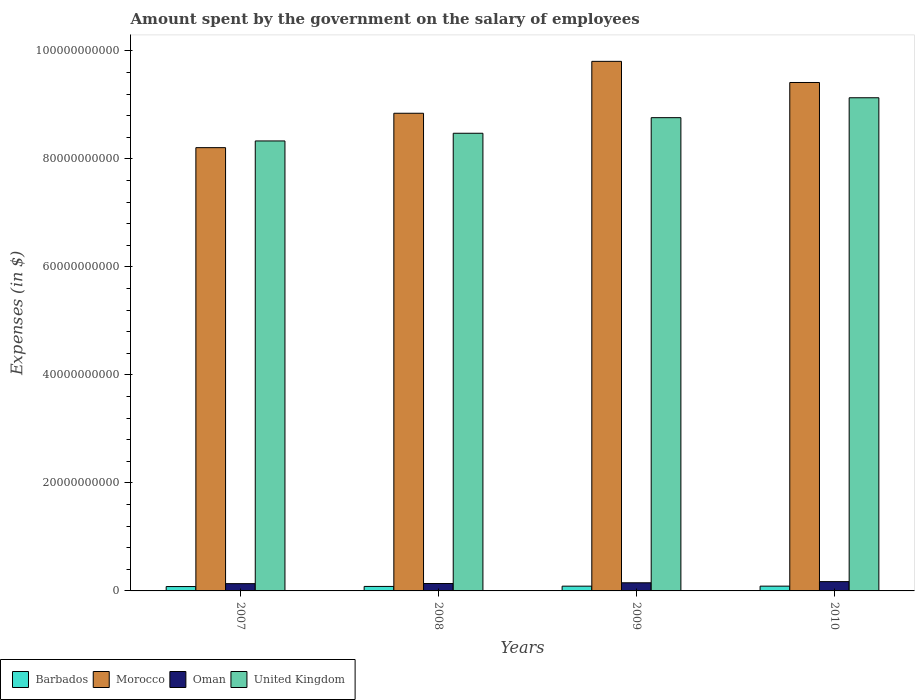How many groups of bars are there?
Keep it short and to the point. 4. Are the number of bars per tick equal to the number of legend labels?
Give a very brief answer. Yes. Are the number of bars on each tick of the X-axis equal?
Your answer should be compact. Yes. How many bars are there on the 4th tick from the left?
Your response must be concise. 4. What is the label of the 3rd group of bars from the left?
Your answer should be compact. 2009. What is the amount spent on the salary of employees by the government in United Kingdom in 2008?
Make the answer very short. 8.48e+1. Across all years, what is the maximum amount spent on the salary of employees by the government in Oman?
Provide a succinct answer. 1.72e+09. Across all years, what is the minimum amount spent on the salary of employees by the government in Barbados?
Your answer should be compact. 8.09e+08. In which year was the amount spent on the salary of employees by the government in United Kingdom maximum?
Offer a very short reply. 2010. In which year was the amount spent on the salary of employees by the government in Oman minimum?
Offer a terse response. 2007. What is the total amount spent on the salary of employees by the government in Oman in the graph?
Offer a very short reply. 5.95e+09. What is the difference between the amount spent on the salary of employees by the government in Oman in 2009 and that in 2010?
Your answer should be very brief. -2.16e+08. What is the difference between the amount spent on the salary of employees by the government in Oman in 2007 and the amount spent on the salary of employees by the government in United Kingdom in 2010?
Give a very brief answer. -9.00e+1. What is the average amount spent on the salary of employees by the government in United Kingdom per year?
Provide a short and direct response. 8.68e+1. In the year 2009, what is the difference between the amount spent on the salary of employees by the government in Barbados and amount spent on the salary of employees by the government in United Kingdom?
Make the answer very short. -8.68e+1. What is the ratio of the amount spent on the salary of employees by the government in Barbados in 2007 to that in 2008?
Offer a terse response. 0.97. What is the difference between the highest and the second highest amount spent on the salary of employees by the government in United Kingdom?
Ensure brevity in your answer.  3.69e+09. What is the difference between the highest and the lowest amount spent on the salary of employees by the government in Morocco?
Provide a succinct answer. 1.60e+1. What does the 4th bar from the left in 2007 represents?
Ensure brevity in your answer.  United Kingdom. What does the 3rd bar from the right in 2009 represents?
Offer a very short reply. Morocco. Are all the bars in the graph horizontal?
Your response must be concise. No. Are the values on the major ticks of Y-axis written in scientific E-notation?
Keep it short and to the point. No. Does the graph contain any zero values?
Ensure brevity in your answer.  No. Does the graph contain grids?
Make the answer very short. No. Where does the legend appear in the graph?
Offer a very short reply. Bottom left. What is the title of the graph?
Keep it short and to the point. Amount spent by the government on the salary of employees. What is the label or title of the X-axis?
Your response must be concise. Years. What is the label or title of the Y-axis?
Offer a very short reply. Expenses (in $). What is the Expenses (in $) of Barbados in 2007?
Offer a very short reply. 8.09e+08. What is the Expenses (in $) of Morocco in 2007?
Your answer should be compact. 8.21e+1. What is the Expenses (in $) of Oman in 2007?
Your response must be concise. 1.35e+09. What is the Expenses (in $) in United Kingdom in 2007?
Offer a terse response. 8.33e+1. What is the Expenses (in $) in Barbados in 2008?
Give a very brief answer. 8.33e+08. What is the Expenses (in $) of Morocco in 2008?
Make the answer very short. 8.85e+1. What is the Expenses (in $) of Oman in 2008?
Make the answer very short. 1.37e+09. What is the Expenses (in $) of United Kingdom in 2008?
Offer a very short reply. 8.48e+1. What is the Expenses (in $) in Barbados in 2009?
Provide a short and direct response. 8.82e+08. What is the Expenses (in $) in Morocco in 2009?
Give a very brief answer. 9.81e+1. What is the Expenses (in $) in Oman in 2009?
Provide a short and direct response. 1.51e+09. What is the Expenses (in $) in United Kingdom in 2009?
Your answer should be compact. 8.77e+1. What is the Expenses (in $) in Barbados in 2010?
Offer a terse response. 8.85e+08. What is the Expenses (in $) in Morocco in 2010?
Provide a succinct answer. 9.42e+1. What is the Expenses (in $) of Oman in 2010?
Give a very brief answer. 1.72e+09. What is the Expenses (in $) of United Kingdom in 2010?
Give a very brief answer. 9.13e+1. Across all years, what is the maximum Expenses (in $) of Barbados?
Give a very brief answer. 8.85e+08. Across all years, what is the maximum Expenses (in $) in Morocco?
Your response must be concise. 9.81e+1. Across all years, what is the maximum Expenses (in $) of Oman?
Your response must be concise. 1.72e+09. Across all years, what is the maximum Expenses (in $) of United Kingdom?
Your answer should be compact. 9.13e+1. Across all years, what is the minimum Expenses (in $) in Barbados?
Your answer should be compact. 8.09e+08. Across all years, what is the minimum Expenses (in $) in Morocco?
Your response must be concise. 8.21e+1. Across all years, what is the minimum Expenses (in $) in Oman?
Your response must be concise. 1.35e+09. Across all years, what is the minimum Expenses (in $) in United Kingdom?
Ensure brevity in your answer.  8.33e+1. What is the total Expenses (in $) in Barbados in the graph?
Ensure brevity in your answer.  3.41e+09. What is the total Expenses (in $) in Morocco in the graph?
Give a very brief answer. 3.63e+11. What is the total Expenses (in $) of Oman in the graph?
Your response must be concise. 5.95e+09. What is the total Expenses (in $) of United Kingdom in the graph?
Ensure brevity in your answer.  3.47e+11. What is the difference between the Expenses (in $) in Barbados in 2007 and that in 2008?
Keep it short and to the point. -2.35e+07. What is the difference between the Expenses (in $) of Morocco in 2007 and that in 2008?
Your answer should be compact. -6.37e+09. What is the difference between the Expenses (in $) of Oman in 2007 and that in 2008?
Your response must be concise. -2.13e+07. What is the difference between the Expenses (in $) of United Kingdom in 2007 and that in 2008?
Provide a succinct answer. -1.42e+09. What is the difference between the Expenses (in $) of Barbados in 2007 and that in 2009?
Keep it short and to the point. -7.31e+07. What is the difference between the Expenses (in $) of Morocco in 2007 and that in 2009?
Make the answer very short. -1.60e+1. What is the difference between the Expenses (in $) of Oman in 2007 and that in 2009?
Make the answer very short. -1.59e+08. What is the difference between the Expenses (in $) of United Kingdom in 2007 and that in 2009?
Your answer should be very brief. -4.31e+09. What is the difference between the Expenses (in $) of Barbados in 2007 and that in 2010?
Offer a very short reply. -7.60e+07. What is the difference between the Expenses (in $) of Morocco in 2007 and that in 2010?
Ensure brevity in your answer.  -1.21e+1. What is the difference between the Expenses (in $) of Oman in 2007 and that in 2010?
Offer a terse response. -3.75e+08. What is the difference between the Expenses (in $) in United Kingdom in 2007 and that in 2010?
Keep it short and to the point. -8.00e+09. What is the difference between the Expenses (in $) of Barbados in 2008 and that in 2009?
Offer a terse response. -4.96e+07. What is the difference between the Expenses (in $) in Morocco in 2008 and that in 2009?
Offer a terse response. -9.61e+09. What is the difference between the Expenses (in $) of Oman in 2008 and that in 2009?
Offer a terse response. -1.37e+08. What is the difference between the Expenses (in $) in United Kingdom in 2008 and that in 2009?
Provide a short and direct response. -2.89e+09. What is the difference between the Expenses (in $) of Barbados in 2008 and that in 2010?
Keep it short and to the point. -5.24e+07. What is the difference between the Expenses (in $) of Morocco in 2008 and that in 2010?
Your answer should be compact. -5.70e+09. What is the difference between the Expenses (in $) in Oman in 2008 and that in 2010?
Give a very brief answer. -3.54e+08. What is the difference between the Expenses (in $) in United Kingdom in 2008 and that in 2010?
Provide a succinct answer. -6.58e+09. What is the difference between the Expenses (in $) of Barbados in 2009 and that in 2010?
Provide a succinct answer. -2.85e+06. What is the difference between the Expenses (in $) in Morocco in 2009 and that in 2010?
Your response must be concise. 3.92e+09. What is the difference between the Expenses (in $) of Oman in 2009 and that in 2010?
Ensure brevity in your answer.  -2.16e+08. What is the difference between the Expenses (in $) in United Kingdom in 2009 and that in 2010?
Your response must be concise. -3.69e+09. What is the difference between the Expenses (in $) in Barbados in 2007 and the Expenses (in $) in Morocco in 2008?
Offer a terse response. -8.77e+1. What is the difference between the Expenses (in $) in Barbados in 2007 and the Expenses (in $) in Oman in 2008?
Provide a short and direct response. -5.60e+08. What is the difference between the Expenses (in $) in Barbados in 2007 and the Expenses (in $) in United Kingdom in 2008?
Give a very brief answer. -8.40e+1. What is the difference between the Expenses (in $) of Morocco in 2007 and the Expenses (in $) of Oman in 2008?
Ensure brevity in your answer.  8.07e+1. What is the difference between the Expenses (in $) in Morocco in 2007 and the Expenses (in $) in United Kingdom in 2008?
Give a very brief answer. -2.67e+09. What is the difference between the Expenses (in $) in Oman in 2007 and the Expenses (in $) in United Kingdom in 2008?
Offer a very short reply. -8.34e+1. What is the difference between the Expenses (in $) of Barbados in 2007 and the Expenses (in $) of Morocco in 2009?
Provide a short and direct response. -9.73e+1. What is the difference between the Expenses (in $) of Barbados in 2007 and the Expenses (in $) of Oman in 2009?
Provide a short and direct response. -6.97e+08. What is the difference between the Expenses (in $) in Barbados in 2007 and the Expenses (in $) in United Kingdom in 2009?
Give a very brief answer. -8.68e+1. What is the difference between the Expenses (in $) of Morocco in 2007 and the Expenses (in $) of Oman in 2009?
Offer a terse response. 8.06e+1. What is the difference between the Expenses (in $) of Morocco in 2007 and the Expenses (in $) of United Kingdom in 2009?
Offer a very short reply. -5.55e+09. What is the difference between the Expenses (in $) of Oman in 2007 and the Expenses (in $) of United Kingdom in 2009?
Your answer should be compact. -8.63e+1. What is the difference between the Expenses (in $) in Barbados in 2007 and the Expenses (in $) in Morocco in 2010?
Your response must be concise. -9.34e+1. What is the difference between the Expenses (in $) in Barbados in 2007 and the Expenses (in $) in Oman in 2010?
Your answer should be very brief. -9.14e+08. What is the difference between the Expenses (in $) of Barbados in 2007 and the Expenses (in $) of United Kingdom in 2010?
Your answer should be very brief. -9.05e+1. What is the difference between the Expenses (in $) in Morocco in 2007 and the Expenses (in $) in Oman in 2010?
Ensure brevity in your answer.  8.04e+1. What is the difference between the Expenses (in $) in Morocco in 2007 and the Expenses (in $) in United Kingdom in 2010?
Give a very brief answer. -9.24e+09. What is the difference between the Expenses (in $) of Oman in 2007 and the Expenses (in $) of United Kingdom in 2010?
Make the answer very short. -9.00e+1. What is the difference between the Expenses (in $) in Barbados in 2008 and the Expenses (in $) in Morocco in 2009?
Your response must be concise. -9.72e+1. What is the difference between the Expenses (in $) in Barbados in 2008 and the Expenses (in $) in Oman in 2009?
Your response must be concise. -6.74e+08. What is the difference between the Expenses (in $) in Barbados in 2008 and the Expenses (in $) in United Kingdom in 2009?
Provide a succinct answer. -8.68e+1. What is the difference between the Expenses (in $) in Morocco in 2008 and the Expenses (in $) in Oman in 2009?
Provide a succinct answer. 8.70e+1. What is the difference between the Expenses (in $) of Morocco in 2008 and the Expenses (in $) of United Kingdom in 2009?
Give a very brief answer. 8.17e+08. What is the difference between the Expenses (in $) of Oman in 2008 and the Expenses (in $) of United Kingdom in 2009?
Ensure brevity in your answer.  -8.63e+1. What is the difference between the Expenses (in $) of Barbados in 2008 and the Expenses (in $) of Morocco in 2010?
Ensure brevity in your answer.  -9.33e+1. What is the difference between the Expenses (in $) of Barbados in 2008 and the Expenses (in $) of Oman in 2010?
Ensure brevity in your answer.  -8.90e+08. What is the difference between the Expenses (in $) in Barbados in 2008 and the Expenses (in $) in United Kingdom in 2010?
Ensure brevity in your answer.  -9.05e+1. What is the difference between the Expenses (in $) of Morocco in 2008 and the Expenses (in $) of Oman in 2010?
Provide a succinct answer. 8.67e+1. What is the difference between the Expenses (in $) of Morocco in 2008 and the Expenses (in $) of United Kingdom in 2010?
Your answer should be very brief. -2.87e+09. What is the difference between the Expenses (in $) in Oman in 2008 and the Expenses (in $) in United Kingdom in 2010?
Ensure brevity in your answer.  -9.00e+1. What is the difference between the Expenses (in $) in Barbados in 2009 and the Expenses (in $) in Morocco in 2010?
Make the answer very short. -9.33e+1. What is the difference between the Expenses (in $) in Barbados in 2009 and the Expenses (in $) in Oman in 2010?
Your answer should be very brief. -8.40e+08. What is the difference between the Expenses (in $) of Barbados in 2009 and the Expenses (in $) of United Kingdom in 2010?
Provide a short and direct response. -9.05e+1. What is the difference between the Expenses (in $) of Morocco in 2009 and the Expenses (in $) of Oman in 2010?
Your answer should be compact. 9.64e+1. What is the difference between the Expenses (in $) in Morocco in 2009 and the Expenses (in $) in United Kingdom in 2010?
Offer a very short reply. 6.74e+09. What is the difference between the Expenses (in $) in Oman in 2009 and the Expenses (in $) in United Kingdom in 2010?
Provide a succinct answer. -8.98e+1. What is the average Expenses (in $) of Barbados per year?
Your answer should be very brief. 8.52e+08. What is the average Expenses (in $) in Morocco per year?
Ensure brevity in your answer.  9.07e+1. What is the average Expenses (in $) of Oman per year?
Your answer should be compact. 1.49e+09. What is the average Expenses (in $) of United Kingdom per year?
Your answer should be very brief. 8.68e+1. In the year 2007, what is the difference between the Expenses (in $) of Barbados and Expenses (in $) of Morocco?
Ensure brevity in your answer.  -8.13e+1. In the year 2007, what is the difference between the Expenses (in $) of Barbados and Expenses (in $) of Oman?
Your answer should be very brief. -5.39e+08. In the year 2007, what is the difference between the Expenses (in $) of Barbados and Expenses (in $) of United Kingdom?
Give a very brief answer. -8.25e+1. In the year 2007, what is the difference between the Expenses (in $) in Morocco and Expenses (in $) in Oman?
Your answer should be very brief. 8.07e+1. In the year 2007, what is the difference between the Expenses (in $) of Morocco and Expenses (in $) of United Kingdom?
Offer a terse response. -1.24e+09. In the year 2007, what is the difference between the Expenses (in $) of Oman and Expenses (in $) of United Kingdom?
Your answer should be very brief. -8.20e+1. In the year 2008, what is the difference between the Expenses (in $) of Barbados and Expenses (in $) of Morocco?
Make the answer very short. -8.76e+1. In the year 2008, what is the difference between the Expenses (in $) of Barbados and Expenses (in $) of Oman?
Your answer should be compact. -5.37e+08. In the year 2008, what is the difference between the Expenses (in $) in Barbados and Expenses (in $) in United Kingdom?
Your answer should be compact. -8.39e+1. In the year 2008, what is the difference between the Expenses (in $) in Morocco and Expenses (in $) in Oman?
Provide a succinct answer. 8.71e+1. In the year 2008, what is the difference between the Expenses (in $) in Morocco and Expenses (in $) in United Kingdom?
Your answer should be very brief. 3.71e+09. In the year 2008, what is the difference between the Expenses (in $) in Oman and Expenses (in $) in United Kingdom?
Offer a very short reply. -8.34e+1. In the year 2009, what is the difference between the Expenses (in $) of Barbados and Expenses (in $) of Morocco?
Provide a short and direct response. -9.72e+1. In the year 2009, what is the difference between the Expenses (in $) in Barbados and Expenses (in $) in Oman?
Make the answer very short. -6.24e+08. In the year 2009, what is the difference between the Expenses (in $) of Barbados and Expenses (in $) of United Kingdom?
Your response must be concise. -8.68e+1. In the year 2009, what is the difference between the Expenses (in $) of Morocco and Expenses (in $) of Oman?
Your response must be concise. 9.66e+1. In the year 2009, what is the difference between the Expenses (in $) in Morocco and Expenses (in $) in United Kingdom?
Make the answer very short. 1.04e+1. In the year 2009, what is the difference between the Expenses (in $) in Oman and Expenses (in $) in United Kingdom?
Make the answer very short. -8.61e+1. In the year 2010, what is the difference between the Expenses (in $) in Barbados and Expenses (in $) in Morocco?
Ensure brevity in your answer.  -9.33e+1. In the year 2010, what is the difference between the Expenses (in $) in Barbados and Expenses (in $) in Oman?
Your response must be concise. -8.38e+08. In the year 2010, what is the difference between the Expenses (in $) of Barbados and Expenses (in $) of United Kingdom?
Keep it short and to the point. -9.05e+1. In the year 2010, what is the difference between the Expenses (in $) in Morocco and Expenses (in $) in Oman?
Offer a very short reply. 9.24e+1. In the year 2010, what is the difference between the Expenses (in $) of Morocco and Expenses (in $) of United Kingdom?
Give a very brief answer. 2.83e+09. In the year 2010, what is the difference between the Expenses (in $) in Oman and Expenses (in $) in United Kingdom?
Give a very brief answer. -8.96e+1. What is the ratio of the Expenses (in $) in Barbados in 2007 to that in 2008?
Make the answer very short. 0.97. What is the ratio of the Expenses (in $) of Morocco in 2007 to that in 2008?
Keep it short and to the point. 0.93. What is the ratio of the Expenses (in $) of Oman in 2007 to that in 2008?
Ensure brevity in your answer.  0.98. What is the ratio of the Expenses (in $) of United Kingdom in 2007 to that in 2008?
Ensure brevity in your answer.  0.98. What is the ratio of the Expenses (in $) in Barbados in 2007 to that in 2009?
Offer a terse response. 0.92. What is the ratio of the Expenses (in $) of Morocco in 2007 to that in 2009?
Offer a very short reply. 0.84. What is the ratio of the Expenses (in $) in Oman in 2007 to that in 2009?
Your response must be concise. 0.89. What is the ratio of the Expenses (in $) in United Kingdom in 2007 to that in 2009?
Provide a succinct answer. 0.95. What is the ratio of the Expenses (in $) of Barbados in 2007 to that in 2010?
Offer a very short reply. 0.91. What is the ratio of the Expenses (in $) in Morocco in 2007 to that in 2010?
Offer a very short reply. 0.87. What is the ratio of the Expenses (in $) of Oman in 2007 to that in 2010?
Provide a short and direct response. 0.78. What is the ratio of the Expenses (in $) of United Kingdom in 2007 to that in 2010?
Keep it short and to the point. 0.91. What is the ratio of the Expenses (in $) of Barbados in 2008 to that in 2009?
Make the answer very short. 0.94. What is the ratio of the Expenses (in $) in Morocco in 2008 to that in 2009?
Make the answer very short. 0.9. What is the ratio of the Expenses (in $) in Oman in 2008 to that in 2009?
Make the answer very short. 0.91. What is the ratio of the Expenses (in $) in Barbados in 2008 to that in 2010?
Offer a terse response. 0.94. What is the ratio of the Expenses (in $) of Morocco in 2008 to that in 2010?
Your answer should be very brief. 0.94. What is the ratio of the Expenses (in $) of Oman in 2008 to that in 2010?
Ensure brevity in your answer.  0.79. What is the ratio of the Expenses (in $) in United Kingdom in 2008 to that in 2010?
Offer a very short reply. 0.93. What is the ratio of the Expenses (in $) of Morocco in 2009 to that in 2010?
Your response must be concise. 1.04. What is the ratio of the Expenses (in $) of Oman in 2009 to that in 2010?
Your answer should be compact. 0.87. What is the ratio of the Expenses (in $) in United Kingdom in 2009 to that in 2010?
Ensure brevity in your answer.  0.96. What is the difference between the highest and the second highest Expenses (in $) in Barbados?
Your response must be concise. 2.85e+06. What is the difference between the highest and the second highest Expenses (in $) in Morocco?
Ensure brevity in your answer.  3.92e+09. What is the difference between the highest and the second highest Expenses (in $) of Oman?
Keep it short and to the point. 2.16e+08. What is the difference between the highest and the second highest Expenses (in $) of United Kingdom?
Keep it short and to the point. 3.69e+09. What is the difference between the highest and the lowest Expenses (in $) in Barbados?
Keep it short and to the point. 7.60e+07. What is the difference between the highest and the lowest Expenses (in $) of Morocco?
Your answer should be very brief. 1.60e+1. What is the difference between the highest and the lowest Expenses (in $) of Oman?
Your response must be concise. 3.75e+08. What is the difference between the highest and the lowest Expenses (in $) in United Kingdom?
Your answer should be compact. 8.00e+09. 